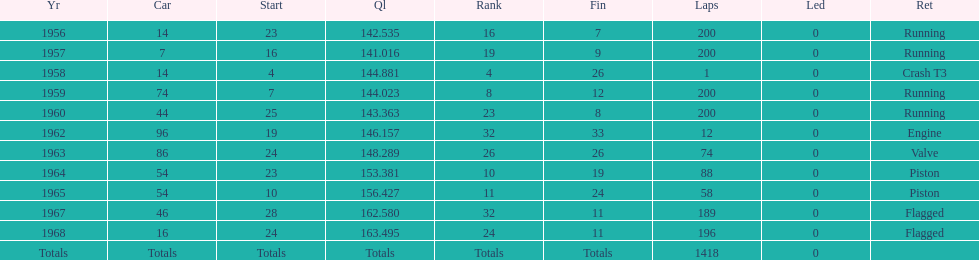What is the larger laps between 1963 or 1968 1968. 